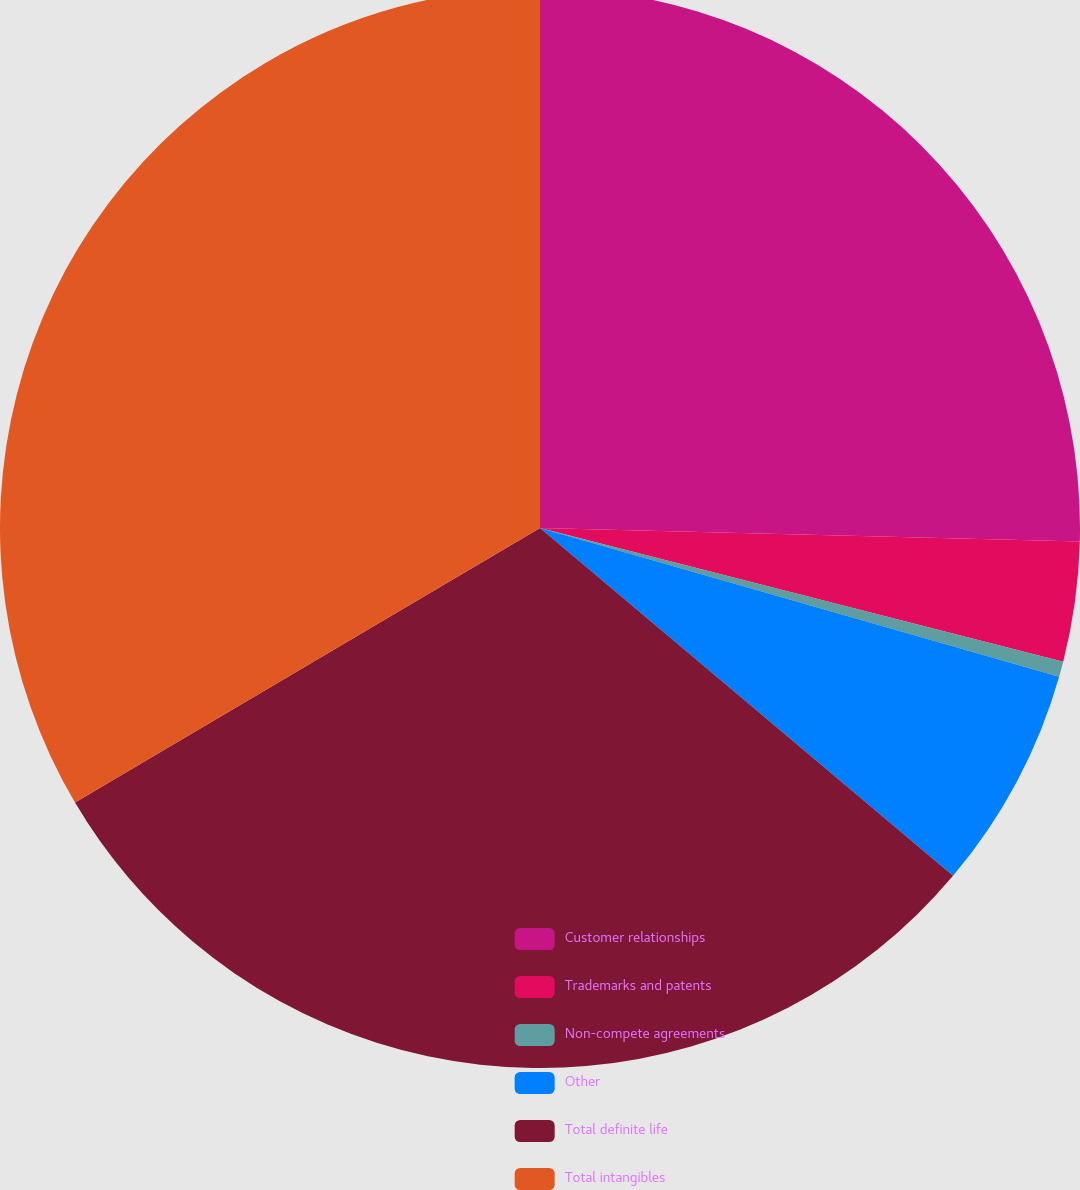Convert chart to OTSL. <chart><loc_0><loc_0><loc_500><loc_500><pie_chart><fcel>Customer relationships<fcel>Trademarks and patents<fcel>Non-compete agreements<fcel>Other<fcel>Total definite life<fcel>Total intangibles<nl><fcel>25.4%<fcel>3.58%<fcel>0.46%<fcel>6.7%<fcel>30.37%<fcel>33.49%<nl></chart> 